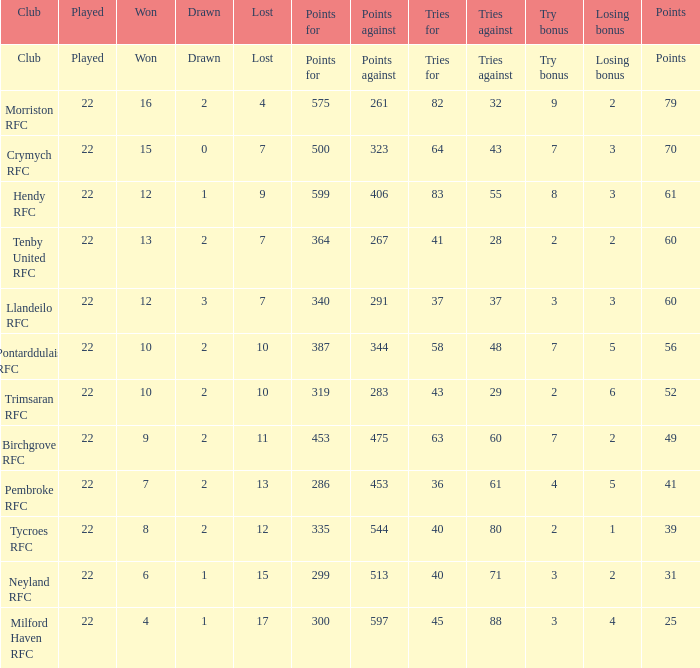What's the club with losing bonus being 1 Tycroes RFC. 